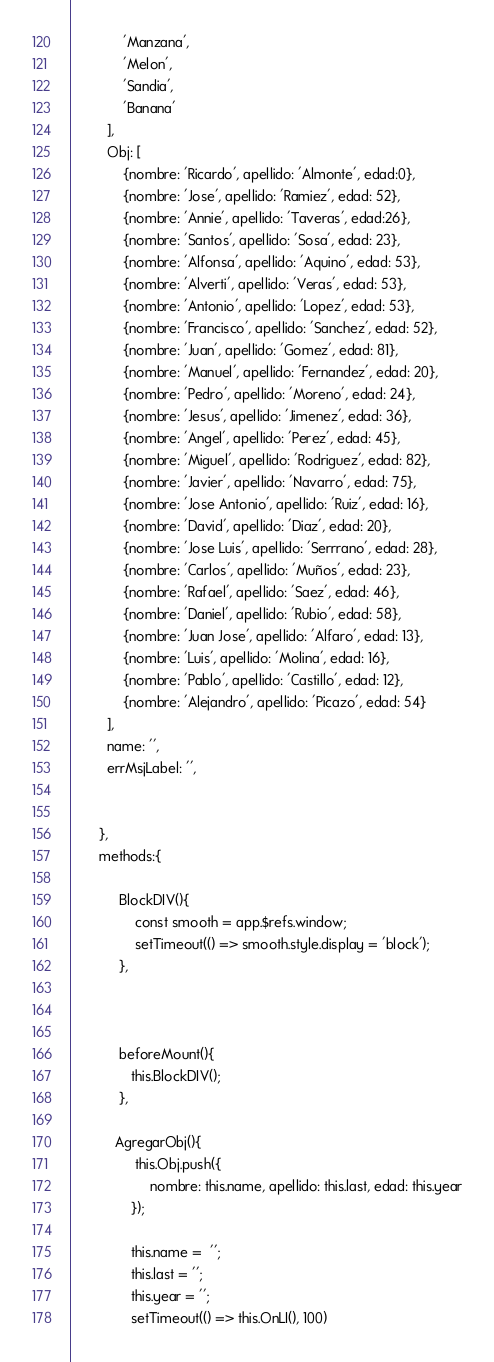<code> <loc_0><loc_0><loc_500><loc_500><_JavaScript_>             'Manzana',
             'Melon',
             'Sandia',
             'Banana'
         ],
         Obj: [
             {nombre: 'Ricardo', apellido: 'Almonte', edad:0},
             {nombre: 'Jose', apellido: 'Ramiez', edad: 52},
             {nombre: 'Annie', apellido: 'Taveras', edad:26},
             {nombre: 'Santos', apellido: 'Sosa', edad: 23},
             {nombre: 'Alfonsa', apellido: 'Aquino', edad: 53},
             {nombre: 'Alverti', apellido: 'Veras', edad: 53},
             {nombre: 'Antonio', apellido: 'Lopez', edad: 53},
             {nombre: 'Francisco', apellido: 'Sanchez', edad: 52},
             {nombre: 'Juan', apellido: 'Gomez', edad: 81},
             {nombre: 'Manuel', apellido: 'Fernandez', edad: 20},
             {nombre: 'Pedro', apellido: 'Moreno', edad: 24},
             {nombre: 'Jesus', apellido: 'Jimenez', edad: 36},
             {nombre: 'Angel', apellido: 'Perez', edad: 45},
             {nombre: 'Miguel', apellido: 'Rodriguez', edad: 82},
             {nombre: 'Javier', apellido: 'Navarro', edad: 75},
             {nombre: 'Jose Antonio', apellido: 'Ruiz', edad: 16},
             {nombre: 'David', apellido: 'Diaz', edad: 20},
             {nombre: 'Jose Luis', apellido: 'Serrrano', edad: 28},
             {nombre: 'Carlos', apellido: 'Muños', edad: 23},
             {nombre: 'Rafael', apellido: 'Saez', edad: 46},
             {nombre: 'Daniel', apellido: 'Rubio', edad: 58},
             {nombre: 'Juan Jose', apellido: 'Alfaro', edad: 13},
             {nombre: 'Luis', apellido: 'Molina', edad: 16},
             {nombre: 'Pablo', apellido: 'Castillo', edad: 12},
             {nombre: 'Alejandro', apellido: 'Picazo', edad: 54}
         ],
         name: '',
         errMsjLabel: '',
        

       },
       methods:{

            BlockDIV(){
                const smooth = app.$refs.window; 
                setTimeout(() => smooth.style.display = 'block');
            },

           

            beforeMount(){
               this.BlockDIV();
            }, 

           AgregarObj(){
                this.Obj.push({
                    nombre: this.name, apellido: this.last, edad: this.year
               });

               this.name =  '';
               this.last = '';
               this.year = '';
               setTimeout(() => this.OnLI(), 100)</code> 